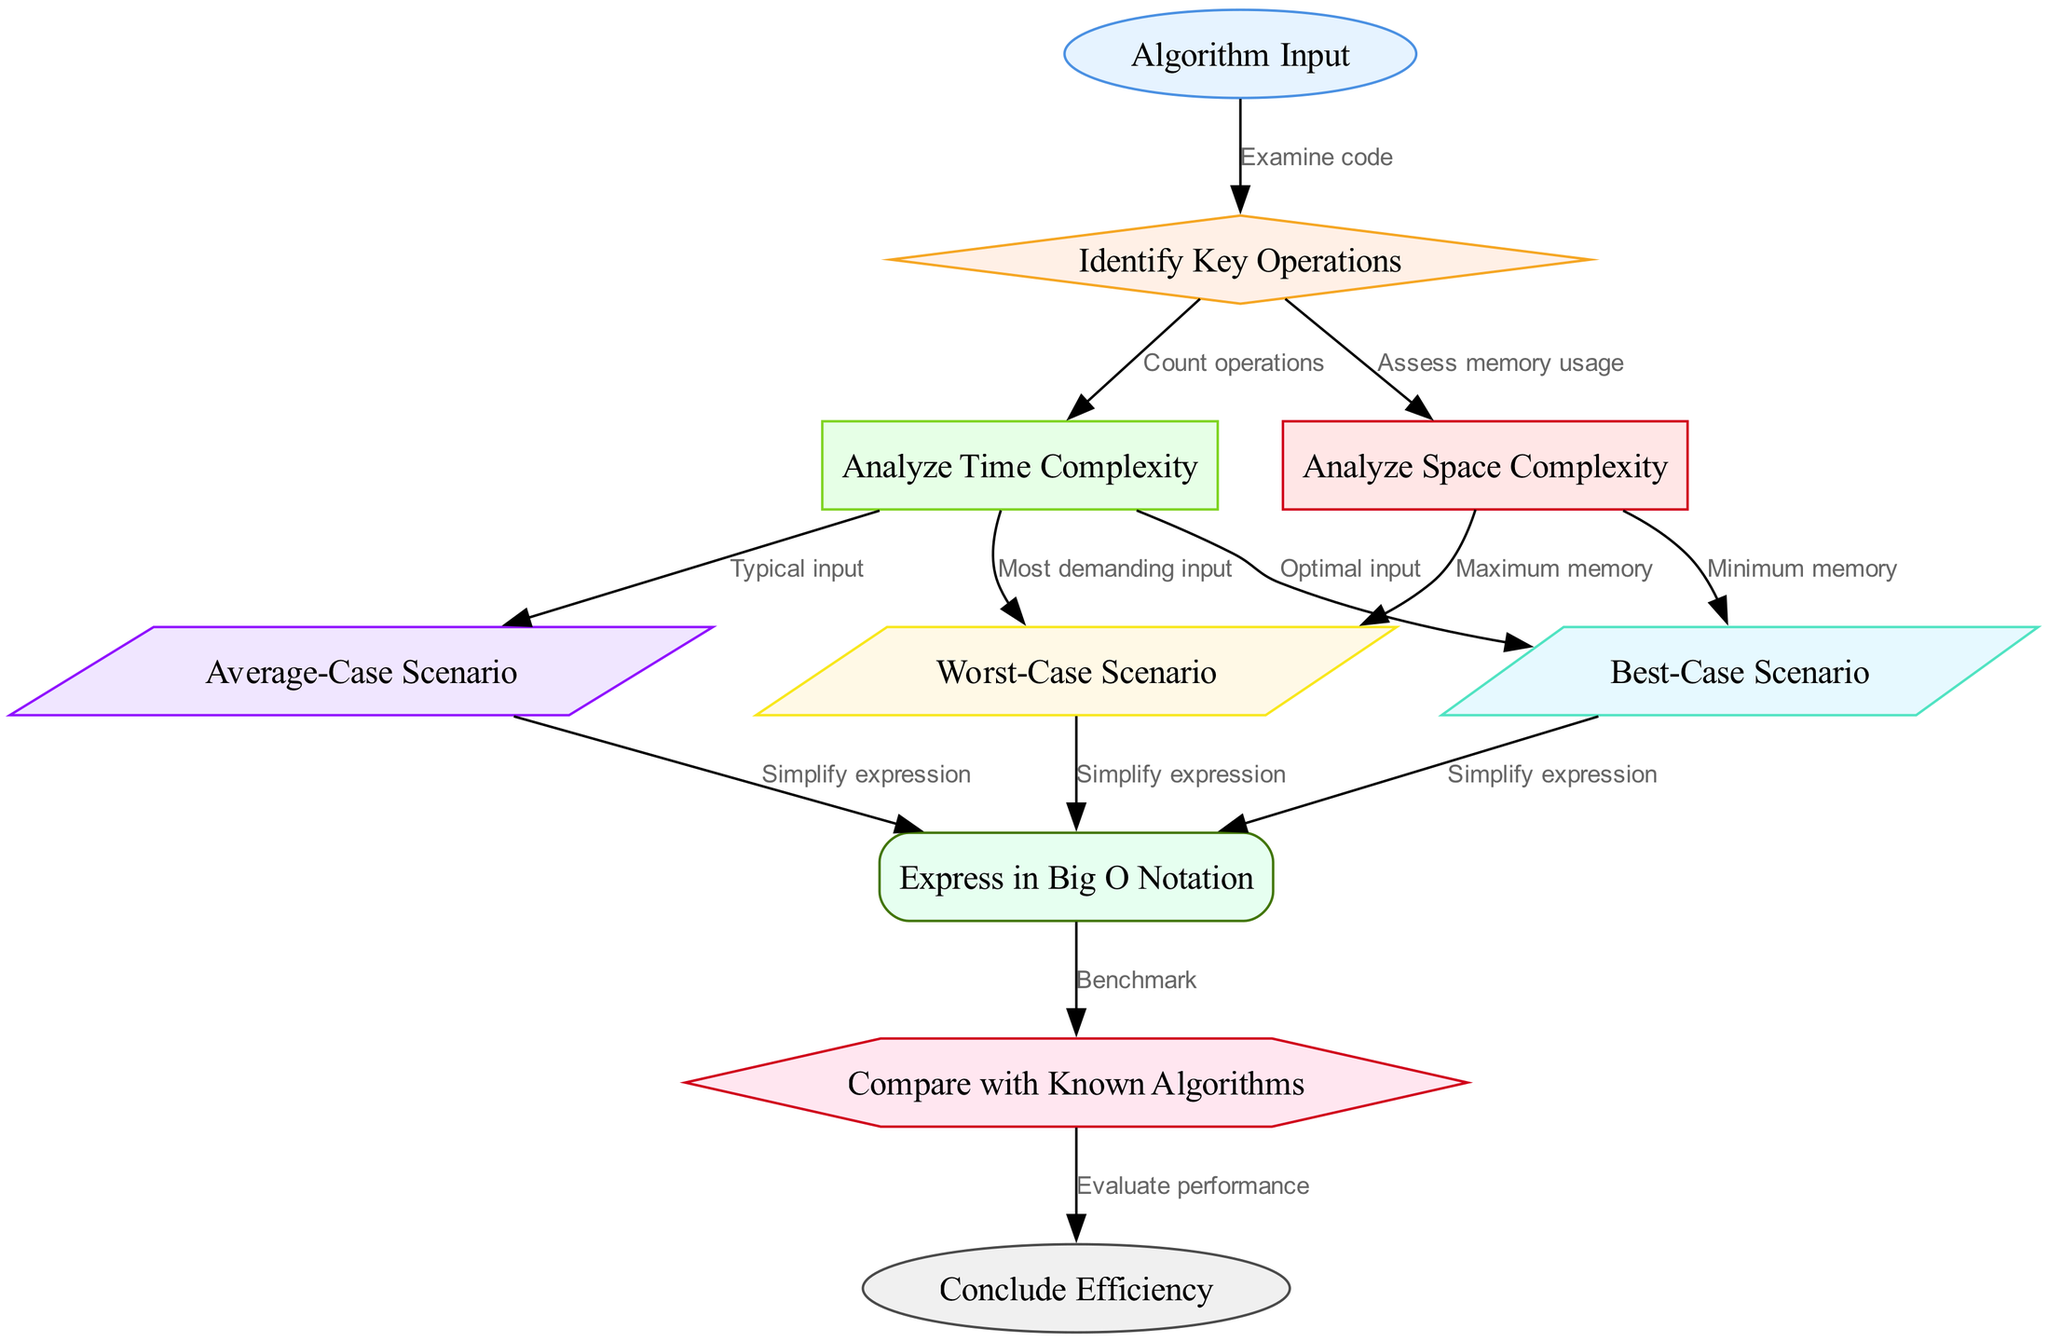What is the first step in the diagram? The first step is labeled "Algorithm Input," which is directly indicated as the starting point of the process in the diagram.
Answer: Algorithm Input How many cases are analyzed for time complexity? The diagram shows three cases: best-case, average-case, and worst-case, each of which is connected to the analyze time complexity node.
Answer: Three What operation follows after assessing memory usage? The next step after assessing memory usage is "Best-Case Scenario," which indicates that the next analysis focuses on the best-case performance of the algorithm.
Answer: Best-Case Scenario What is the node shape for "Big O Notation"? The node "Express in Big O Notation" is represented in a box shape with rounded corners based on the styles defined in the diagram.
Answer: Box What is the final action taken in the process? The final action in the flowchart is "Conclude Efficiency," which wraps up the analysis process by summarizing the findings based on previous evaluations.
Answer: Conclude Efficiency Which node comes after "Average-Case Scenario"? After "Average-Case Scenario," the process goes to "Express in Big O Notation," indicating that simplification follows typical case analysis.
Answer: Express in Big O Notation Which nodes represent scenarios for space complexity? The nodes "Minimum memory" for best case and "Maximum memory" for worst case represent the scenarios considered in space complexity analysis.
Answer: Minimum memory, Maximum memory What is the connection between "Big O Notation" and "Compare with Known Algorithms"? The connection indicates that after simplifying the time and space complexities to Big O Notation, the next step is to benchmark this notation against known algorithms to evaluate performance.
Answer: Benchmark What type of node is "Identify Key Operations"? "Identify Key Operations" is a diamond-shaped node in the diagram, making it distinct and indicating a decision or critical analysis step in the process.
Answer: Diamond 